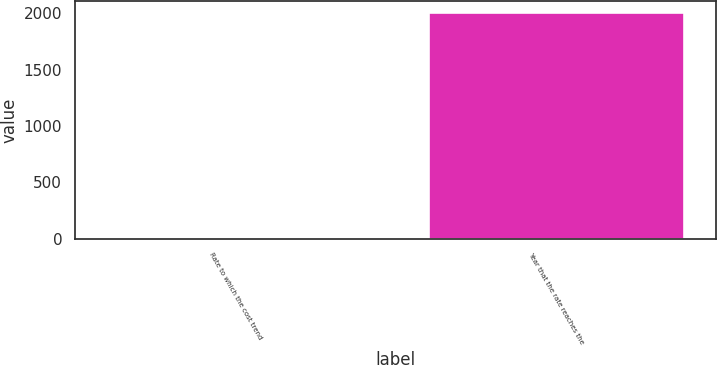Convert chart to OTSL. <chart><loc_0><loc_0><loc_500><loc_500><bar_chart><fcel>Rate to which the cost trend<fcel>Year that the rate reaches the<nl><fcel>5<fcel>2009<nl></chart> 